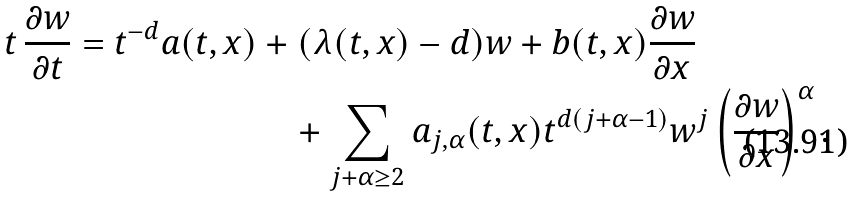Convert formula to latex. <formula><loc_0><loc_0><loc_500><loc_500>t \, \frac { \partial w } { \partial t } = t ^ { - d } a ( t , x ) & + ( \lambda ( t , x ) - d ) w + b ( t , x ) \frac { \partial w } { \partial x } \\ & \quad + \sum _ { j + \alpha \geq 2 } a _ { j , \alpha } ( t , x ) t ^ { d ( j + \alpha - 1 ) } w ^ { j } \left ( \frac { \partial w } { \partial x } \right ) ^ { \alpha } .</formula> 